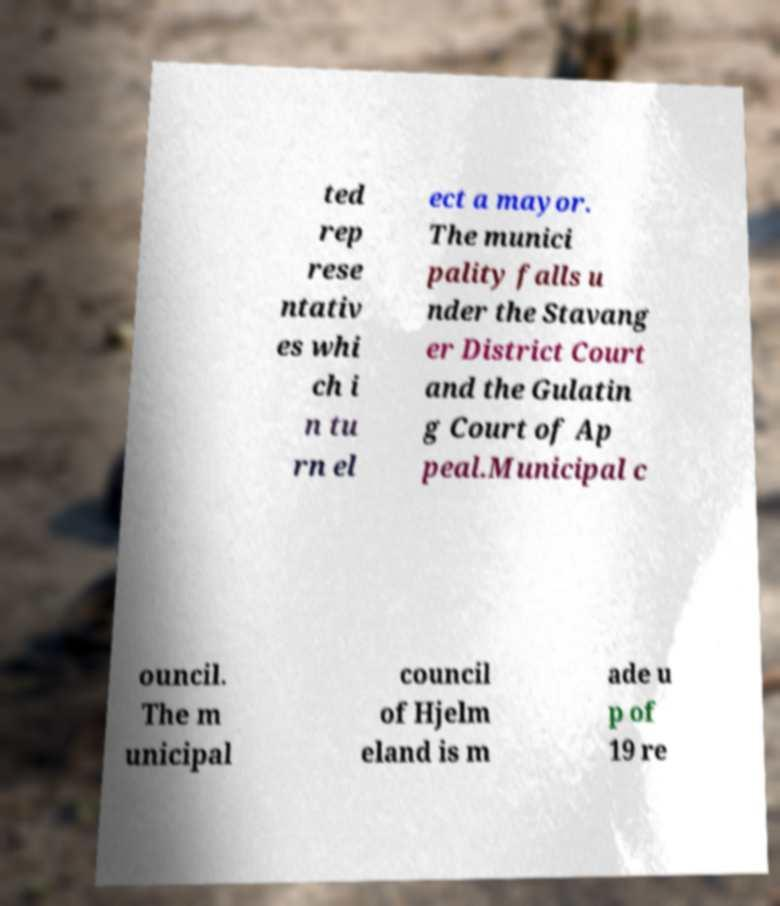I need the written content from this picture converted into text. Can you do that? ted rep rese ntativ es whi ch i n tu rn el ect a mayor. The munici pality falls u nder the Stavang er District Court and the Gulatin g Court of Ap peal.Municipal c ouncil. The m unicipal council of Hjelm eland is m ade u p of 19 re 